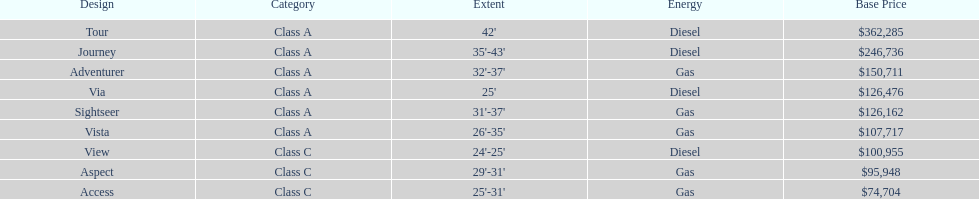Which model had the highest starting price Tour. 